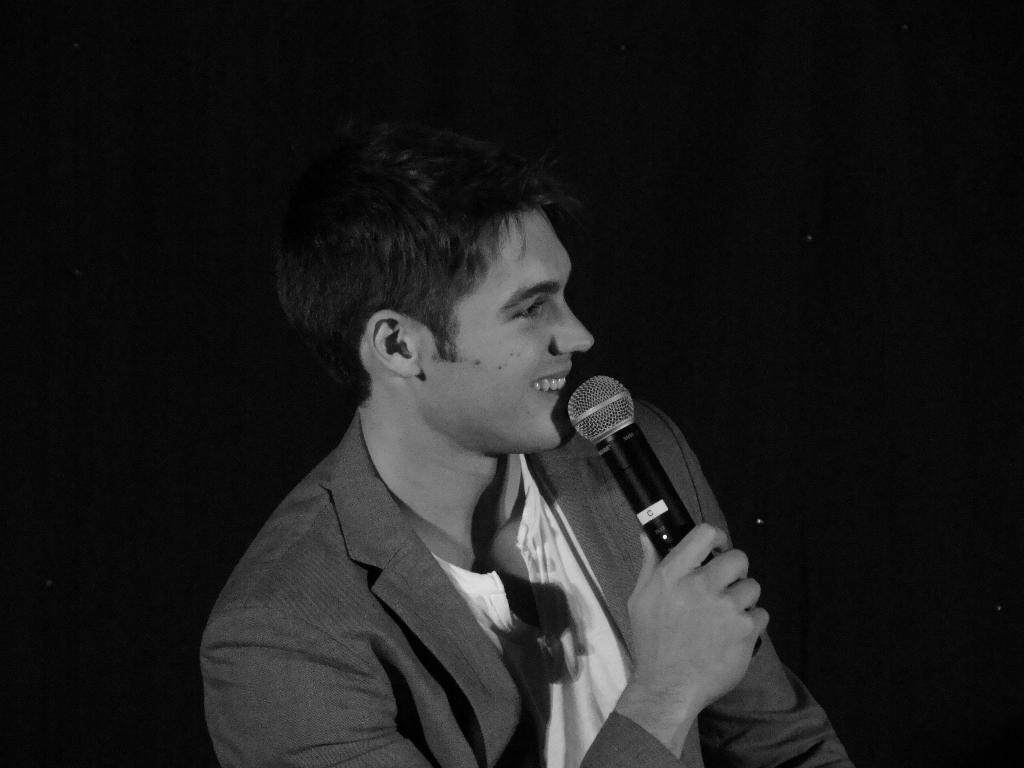What is the main subject of the image? The main subject of the image is a man. What is the man holding in the image? The man is holding a microphone. What expression does the man have in the image? The man is smiling. What type of clothing is the man wearing in the image? The man is wearing a coat. What type of furniture can be seen in the background of the image? There is no furniture visible in the image; it only features a man holding a microphone. Can you describe the yard where the man is standing in the image? There is no yard present in the image; it is focused on the man and his surroundings do not include a yard. 